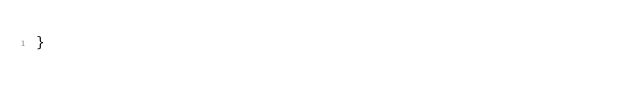Convert code to text. <code><loc_0><loc_0><loc_500><loc_500><_Java_>}
</code> 